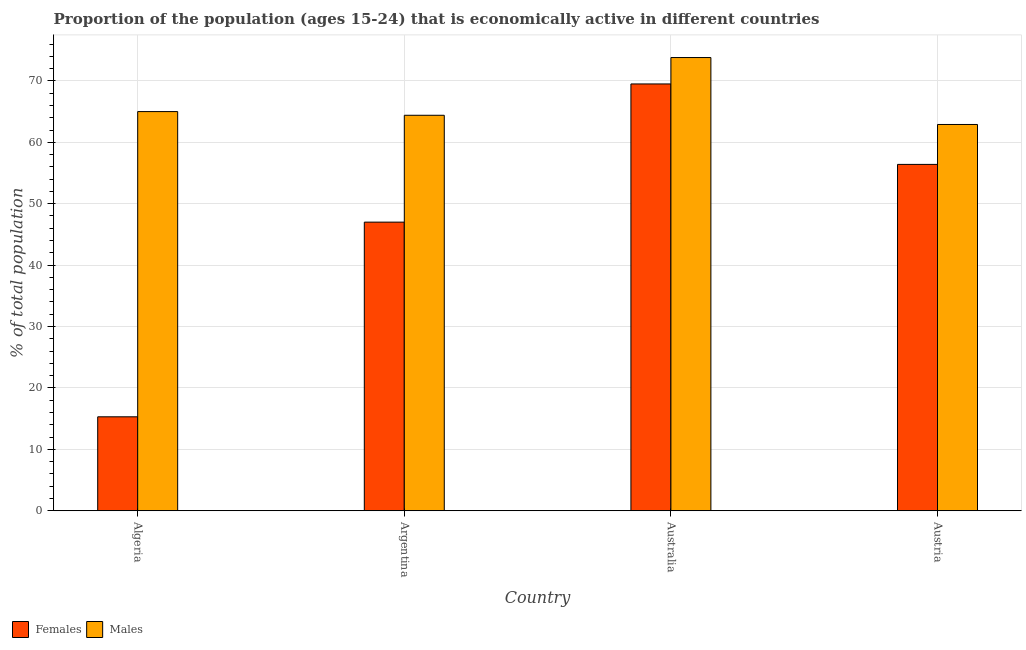How many groups of bars are there?
Ensure brevity in your answer.  4. Are the number of bars per tick equal to the number of legend labels?
Make the answer very short. Yes. Are the number of bars on each tick of the X-axis equal?
Keep it short and to the point. Yes. What is the label of the 2nd group of bars from the left?
Make the answer very short. Argentina. In how many cases, is the number of bars for a given country not equal to the number of legend labels?
Offer a very short reply. 0. Across all countries, what is the maximum percentage of economically active female population?
Ensure brevity in your answer.  69.5. Across all countries, what is the minimum percentage of economically active female population?
Offer a very short reply. 15.3. In which country was the percentage of economically active female population minimum?
Your response must be concise. Algeria. What is the total percentage of economically active male population in the graph?
Keep it short and to the point. 266.1. What is the difference between the percentage of economically active male population in Algeria and that in Austria?
Give a very brief answer. 2.1. What is the difference between the percentage of economically active female population in Argentina and the percentage of economically active male population in Austria?
Your answer should be very brief. -15.9. What is the average percentage of economically active male population per country?
Your answer should be compact. 66.53. What is the difference between the percentage of economically active female population and percentage of economically active male population in Argentina?
Provide a succinct answer. -17.4. In how many countries, is the percentage of economically active female population greater than 62 %?
Provide a short and direct response. 1. What is the ratio of the percentage of economically active female population in Argentina to that in Austria?
Offer a terse response. 0.83. Is the difference between the percentage of economically active female population in Algeria and Austria greater than the difference between the percentage of economically active male population in Algeria and Austria?
Your answer should be very brief. No. What is the difference between the highest and the second highest percentage of economically active female population?
Ensure brevity in your answer.  13.1. What is the difference between the highest and the lowest percentage of economically active female population?
Your answer should be very brief. 54.2. In how many countries, is the percentage of economically active male population greater than the average percentage of economically active male population taken over all countries?
Keep it short and to the point. 1. What does the 1st bar from the left in Australia represents?
Your response must be concise. Females. What does the 2nd bar from the right in Australia represents?
Your answer should be very brief. Females. How many bars are there?
Offer a terse response. 8. Does the graph contain any zero values?
Keep it short and to the point. No. Does the graph contain grids?
Provide a succinct answer. Yes. How are the legend labels stacked?
Your answer should be compact. Horizontal. What is the title of the graph?
Provide a succinct answer. Proportion of the population (ages 15-24) that is economically active in different countries. What is the label or title of the X-axis?
Your answer should be compact. Country. What is the label or title of the Y-axis?
Your answer should be very brief. % of total population. What is the % of total population in Females in Algeria?
Provide a short and direct response. 15.3. What is the % of total population of Males in Argentina?
Keep it short and to the point. 64.4. What is the % of total population in Females in Australia?
Offer a terse response. 69.5. What is the % of total population in Males in Australia?
Provide a short and direct response. 73.8. What is the % of total population in Females in Austria?
Make the answer very short. 56.4. What is the % of total population in Males in Austria?
Make the answer very short. 62.9. Across all countries, what is the maximum % of total population of Females?
Offer a terse response. 69.5. Across all countries, what is the maximum % of total population of Males?
Make the answer very short. 73.8. Across all countries, what is the minimum % of total population in Females?
Offer a very short reply. 15.3. Across all countries, what is the minimum % of total population of Males?
Offer a very short reply. 62.9. What is the total % of total population of Females in the graph?
Keep it short and to the point. 188.2. What is the total % of total population in Males in the graph?
Offer a very short reply. 266.1. What is the difference between the % of total population in Females in Algeria and that in Argentina?
Your answer should be very brief. -31.7. What is the difference between the % of total population in Males in Algeria and that in Argentina?
Give a very brief answer. 0.6. What is the difference between the % of total population of Females in Algeria and that in Australia?
Ensure brevity in your answer.  -54.2. What is the difference between the % of total population of Males in Algeria and that in Australia?
Offer a terse response. -8.8. What is the difference between the % of total population in Females in Algeria and that in Austria?
Keep it short and to the point. -41.1. What is the difference between the % of total population in Females in Argentina and that in Australia?
Offer a very short reply. -22.5. What is the difference between the % of total population in Females in Argentina and that in Austria?
Offer a very short reply. -9.4. What is the difference between the % of total population of Males in Argentina and that in Austria?
Your answer should be compact. 1.5. What is the difference between the % of total population in Females in Australia and that in Austria?
Keep it short and to the point. 13.1. What is the difference between the % of total population of Males in Australia and that in Austria?
Keep it short and to the point. 10.9. What is the difference between the % of total population of Females in Algeria and the % of total population of Males in Argentina?
Your answer should be very brief. -49.1. What is the difference between the % of total population of Females in Algeria and the % of total population of Males in Australia?
Make the answer very short. -58.5. What is the difference between the % of total population of Females in Algeria and the % of total population of Males in Austria?
Offer a terse response. -47.6. What is the difference between the % of total population in Females in Argentina and the % of total population in Males in Australia?
Provide a short and direct response. -26.8. What is the difference between the % of total population in Females in Argentina and the % of total population in Males in Austria?
Keep it short and to the point. -15.9. What is the difference between the % of total population of Females in Australia and the % of total population of Males in Austria?
Provide a succinct answer. 6.6. What is the average % of total population of Females per country?
Provide a short and direct response. 47.05. What is the average % of total population of Males per country?
Offer a terse response. 66.53. What is the difference between the % of total population in Females and % of total population in Males in Algeria?
Offer a terse response. -49.7. What is the difference between the % of total population in Females and % of total population in Males in Argentina?
Offer a terse response. -17.4. What is the difference between the % of total population in Females and % of total population in Males in Austria?
Give a very brief answer. -6.5. What is the ratio of the % of total population of Females in Algeria to that in Argentina?
Keep it short and to the point. 0.33. What is the ratio of the % of total population of Males in Algeria to that in Argentina?
Offer a very short reply. 1.01. What is the ratio of the % of total population in Females in Algeria to that in Australia?
Provide a short and direct response. 0.22. What is the ratio of the % of total population of Males in Algeria to that in Australia?
Your answer should be compact. 0.88. What is the ratio of the % of total population of Females in Algeria to that in Austria?
Provide a succinct answer. 0.27. What is the ratio of the % of total population in Males in Algeria to that in Austria?
Your answer should be very brief. 1.03. What is the ratio of the % of total population in Females in Argentina to that in Australia?
Offer a terse response. 0.68. What is the ratio of the % of total population of Males in Argentina to that in Australia?
Provide a succinct answer. 0.87. What is the ratio of the % of total population in Males in Argentina to that in Austria?
Offer a terse response. 1.02. What is the ratio of the % of total population in Females in Australia to that in Austria?
Provide a short and direct response. 1.23. What is the ratio of the % of total population of Males in Australia to that in Austria?
Give a very brief answer. 1.17. What is the difference between the highest and the second highest % of total population in Females?
Ensure brevity in your answer.  13.1. What is the difference between the highest and the second highest % of total population in Males?
Offer a terse response. 8.8. What is the difference between the highest and the lowest % of total population of Females?
Offer a terse response. 54.2. What is the difference between the highest and the lowest % of total population in Males?
Your answer should be compact. 10.9. 